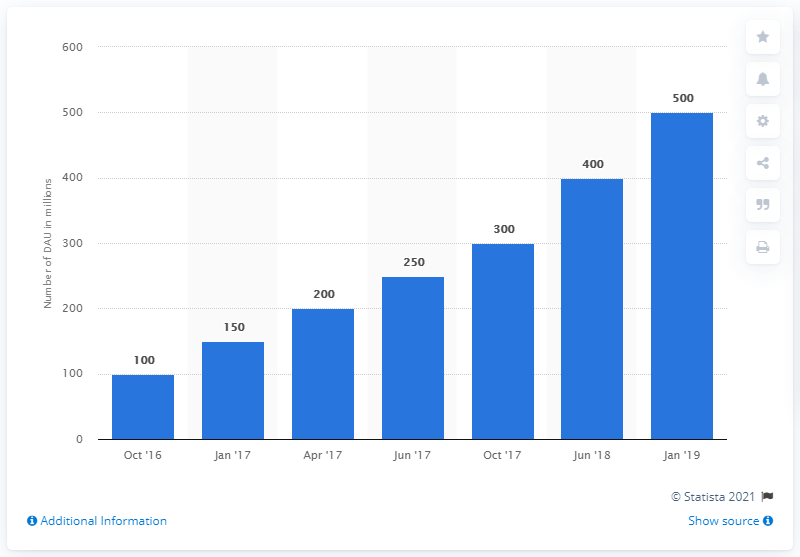Mention a couple of crucial points in this snapshot. In January 2019, there were approximately 500 daily active stories users on Instagram. 